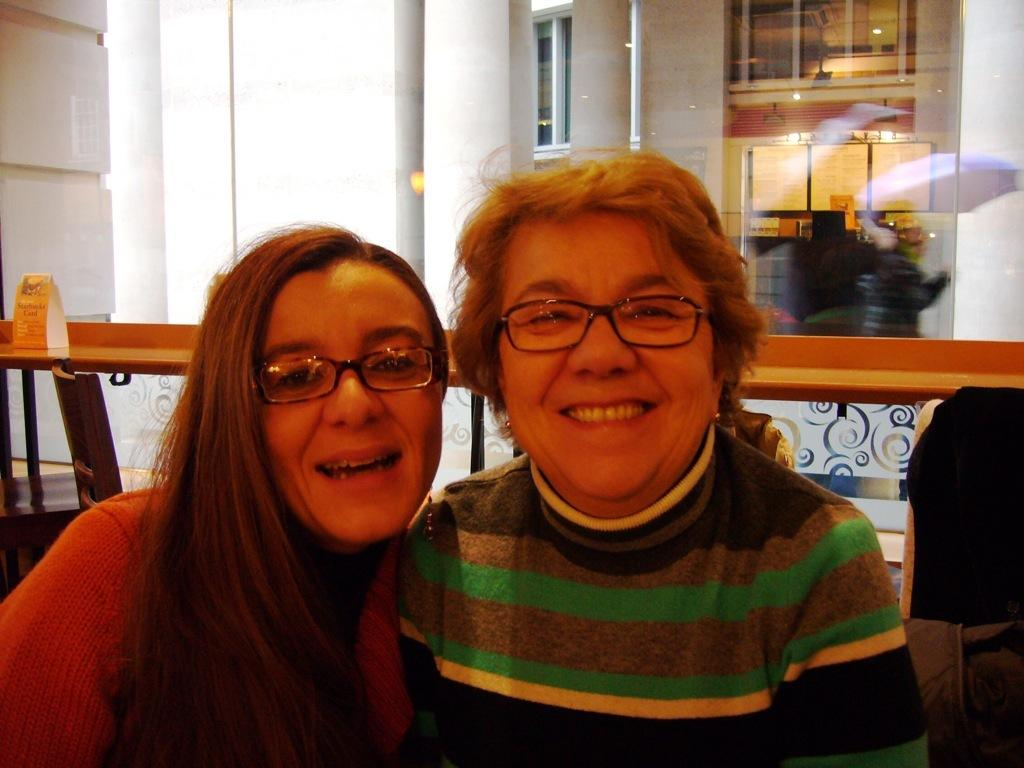How many women are in the image? There are two women in the image. What expression do the women have? The women are smiling. What is on the table in the image? There is a board on the table. What architectural features can be seen in the background of the image? There are pillars in the background of the image. What type of windows are present in the background of the image? There are glass windows on the wall in the background of the image. What color are the girl's toes in the image? There is no girl present in the image, and therefore no toes to describe. 